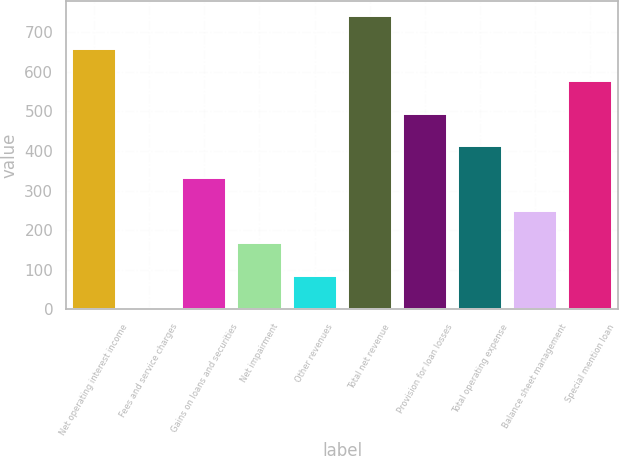<chart> <loc_0><loc_0><loc_500><loc_500><bar_chart><fcel>Net operating interest income<fcel>Fees and service charges<fcel>Gains on loans and securities<fcel>Net impairment<fcel>Other revenues<fcel>Total net revenue<fcel>Provision for loan losses<fcel>Total operating expense<fcel>Balance sheet management<fcel>Special mention loan<nl><fcel>658.72<fcel>2.4<fcel>330.56<fcel>166.48<fcel>84.44<fcel>740.76<fcel>494.64<fcel>412.6<fcel>248.52<fcel>576.68<nl></chart> 